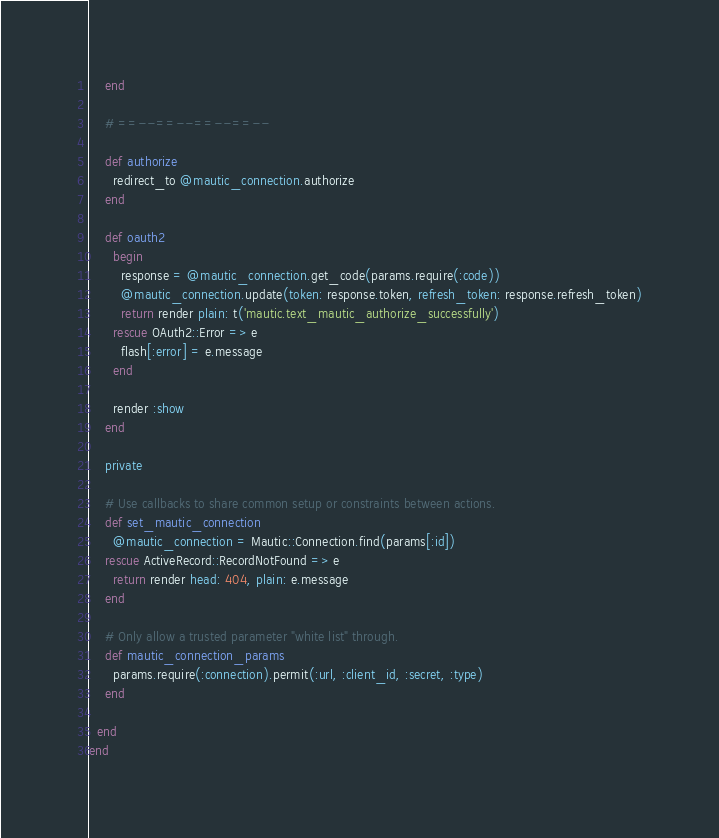Convert code to text. <code><loc_0><loc_0><loc_500><loc_500><_Ruby_>    end

    # ==--==--==--==--

    def authorize
      redirect_to @mautic_connection.authorize
    end

    def oauth2
      begin
        response = @mautic_connection.get_code(params.require(:code))
        @mautic_connection.update(token: response.token, refresh_token: response.refresh_token)
        return render plain: t('mautic.text_mautic_authorize_successfully')
      rescue OAuth2::Error => e
        flash[:error] = e.message
      end

      render :show
    end

    private

    # Use callbacks to share common setup or constraints between actions.
    def set_mautic_connection
      @mautic_connection = Mautic::Connection.find(params[:id])
    rescue ActiveRecord::RecordNotFound => e
      return render head: 404, plain: e.message
    end

    # Only allow a trusted parameter "white list" through.
    def mautic_connection_params
      params.require(:connection).permit(:url, :client_id, :secret, :type)
    end

  end
end</code> 